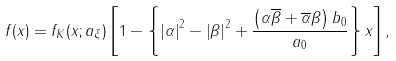Convert formula to latex. <formula><loc_0><loc_0><loc_500><loc_500>f ( x ) = f _ { K } ( x ; a _ { \xi } ) \left [ 1 - \left \{ \left | \alpha \right | ^ { 2 } - \left | \beta \right | ^ { 2 } + \frac { \left ( \alpha \overline { \beta } + \overline { \alpha } \beta \right ) b _ { 0 } } { a _ { 0 } } \right \} x \right ] ,</formula> 